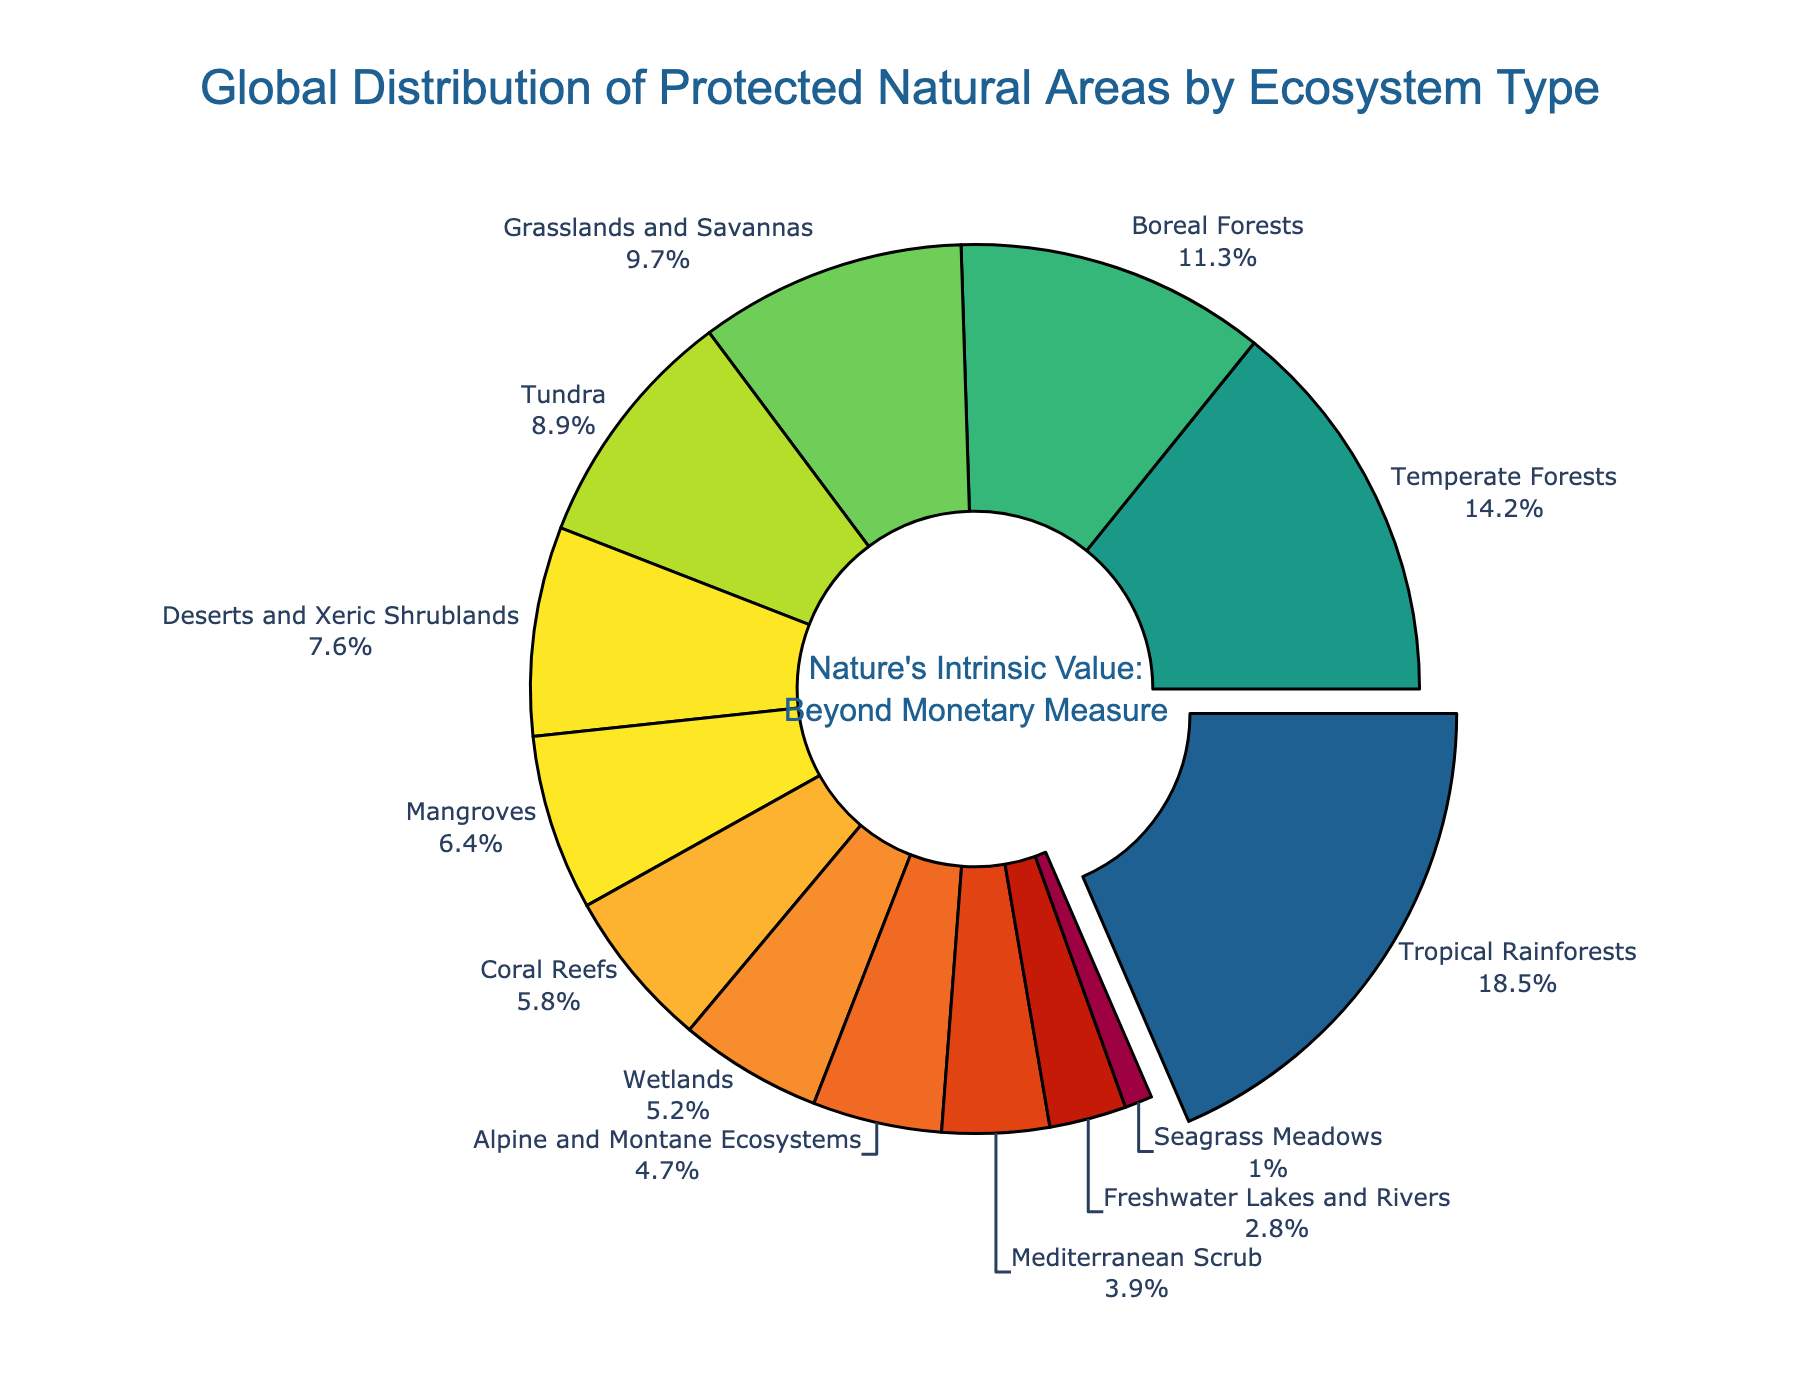What is the largest ecosystem type by the percentage of protected areas? The figure shows that Tropical Rainforests occupy the largest segment, indicated by the slightly pulled-out section of the pie chart.
Answer: Tropical Rainforests Which two ecosystem types together make up more than 20% of protected areas? Tropical Rainforests (18.5%) and Temperate Forests (14.2%) together make up 18.5% + 14.2% = 32.7%, which is more than 20%.
Answer: Tropical Rainforests and Temperate Forests How does the percentage of Tundra compare to that of Grasslands and Savannas? By looking at the percentages, Tundra (8.9%) is slightly less than Grasslands and Savannas (9.7%).
Answer: Tundra is slightly less Which ecosystem type has the smallest percentage of protected areas, and what is it? By examining the pie chart, Seagrass Meadows has the smallest percentage of protected areas at 1.0%.
Answer: Seagrass Meadows What is the total percentage of all forest types combined? Adding the percentages of Tropical Rainforests (18.5%), Temperate Forests (14.2%), and Boreal Forests (11.3%) gives a total of 18.5 + 14.2 + 11.3 = 44.0%.
Answer: 44.0% How does the sum of percentages of Deserts and Xeric Shrublands and Coral Reefs compare to the percentage of Wetlands? Deserts and Xeric Shrublands (7.6%) + Coral Reefs (5.8%) = 13.4%, whereas Wetlands is 5.2%, so 13.4% is greater than 5.2%.
Answer: 13.4% is greater Which category has a higher percentage, Mangroves or Alpine and Montane Ecosystems? Mangroves (6.4%) have a higher percentage than Alpine and Montane Ecosystems (4.7%).
Answer: Mangroves What is the approximate sum of the percentages of the three least represented ecosystem types in protected areas? Summing Seagrass Meadows (1.0%), Freshwater Lakes and Rivers (2.8%), and Mediterranean Scrub (3.9%) gives approximately 7.7%.
Answer: 7.7% What percentage more protected area do Boreal Forests have compared to Seagrass Meadows? Boreal Forests (11.3%) have 11.3% - 1.0% = 10.3% more protected area than Seagrass Meadows.
Answer: 10.3% How much larger is the percentage of Temperate Forests compared to Freshwater Lakes and Rivers? Temperate Forests account for 14.2%, and Freshwater Lakes and Rivers account for 2.8%. The difference is 14.2% - 2.8% = 11.4%.
Answer: 11.4% 